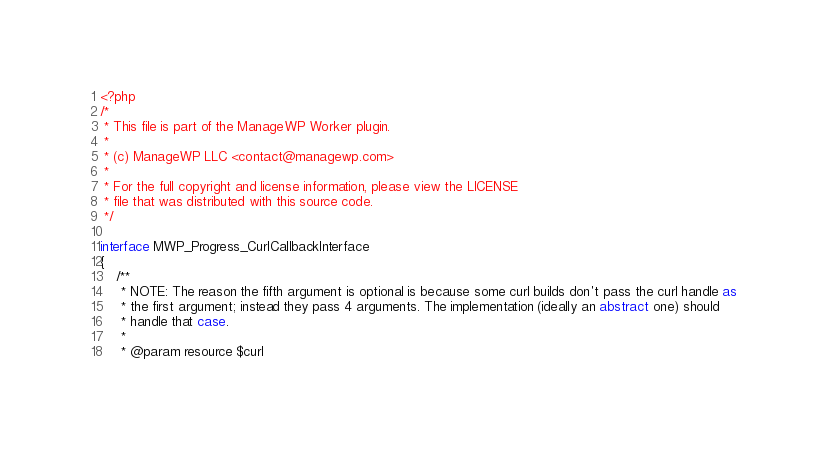<code> <loc_0><loc_0><loc_500><loc_500><_PHP_><?php
/*
 * This file is part of the ManageWP Worker plugin.
 *
 * (c) ManageWP LLC <contact@managewp.com>
 *
 * For the full copyright and license information, please view the LICENSE
 * file that was distributed with this source code.
 */

interface MWP_Progress_CurlCallbackInterface
{
    /**
     * NOTE: The reason the fifth argument is optional is because some curl builds don't pass the curl handle as
     * the first argument; instead they pass 4 arguments. The implementation (ideally an abstract one) should
     * handle that case.
     *
     * @param resource $curl</code> 